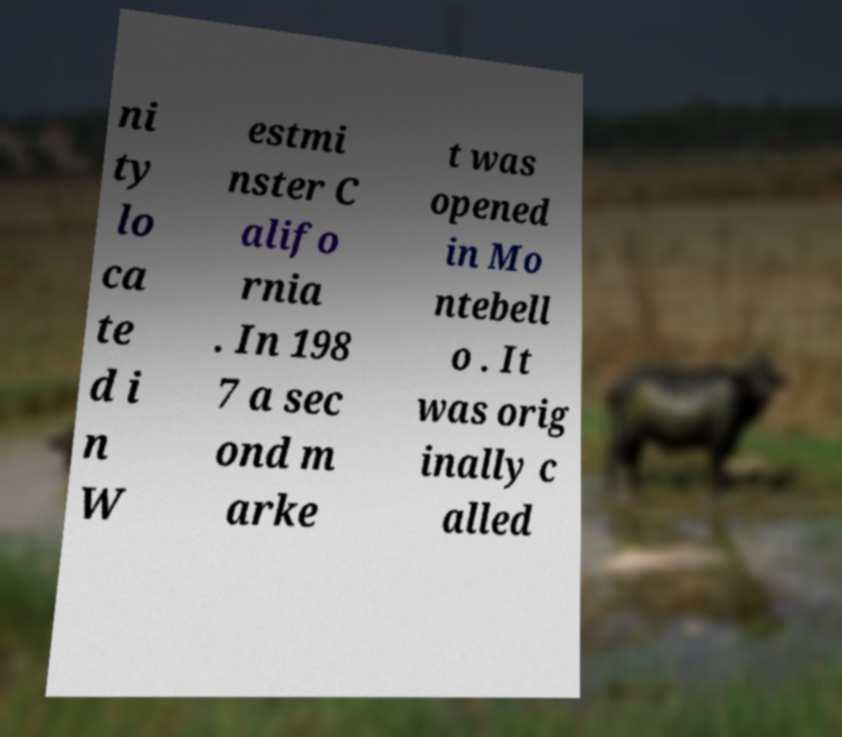Can you read and provide the text displayed in the image?This photo seems to have some interesting text. Can you extract and type it out for me? ni ty lo ca te d i n W estmi nster C alifo rnia . In 198 7 a sec ond m arke t was opened in Mo ntebell o . It was orig inally c alled 